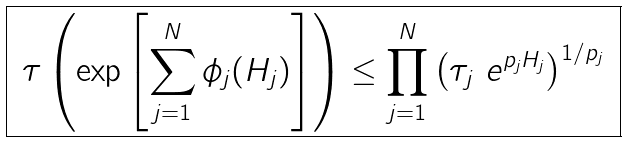<formula> <loc_0><loc_0><loc_500><loc_500>\boxed { \ \tau \left ( \exp \left [ \sum _ { j = 1 } ^ { N } \phi _ { j } ( H _ { j } ) \right ] \right ) \leq \prod _ { j = 1 } ^ { N } \left ( \tau _ { j } \ e ^ { p _ { j } H _ { j } } \right ) ^ { 1 / p _ { j } } \ }</formula> 